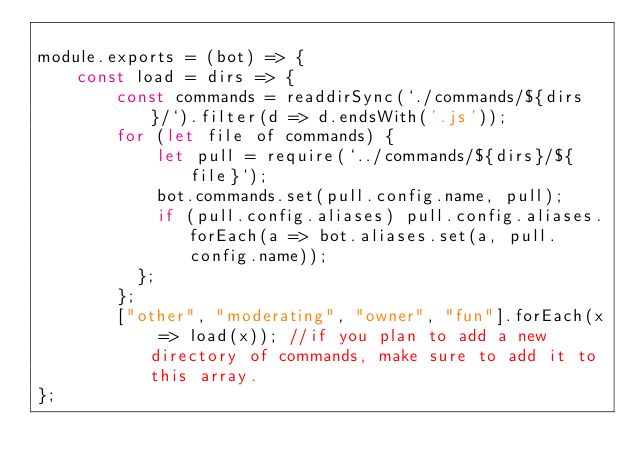<code> <loc_0><loc_0><loc_500><loc_500><_JavaScript_>
module.exports = (bot) => {
    const load = dirs => {
        const commands = readdirSync(`./commands/${dirs}/`).filter(d => d.endsWith('.js'));
        for (let file of commands) {
            let pull = require(`../commands/${dirs}/${file}`);
            bot.commands.set(pull.config.name, pull);
            if (pull.config.aliases) pull.config.aliases.forEach(a => bot.aliases.set(a, pull.config.name));
          };
        };
        ["other", "moderating", "owner", "fun"].forEach(x => load(x)); //if you plan to add a new directory of commands, make sure to add it to this array.
};</code> 